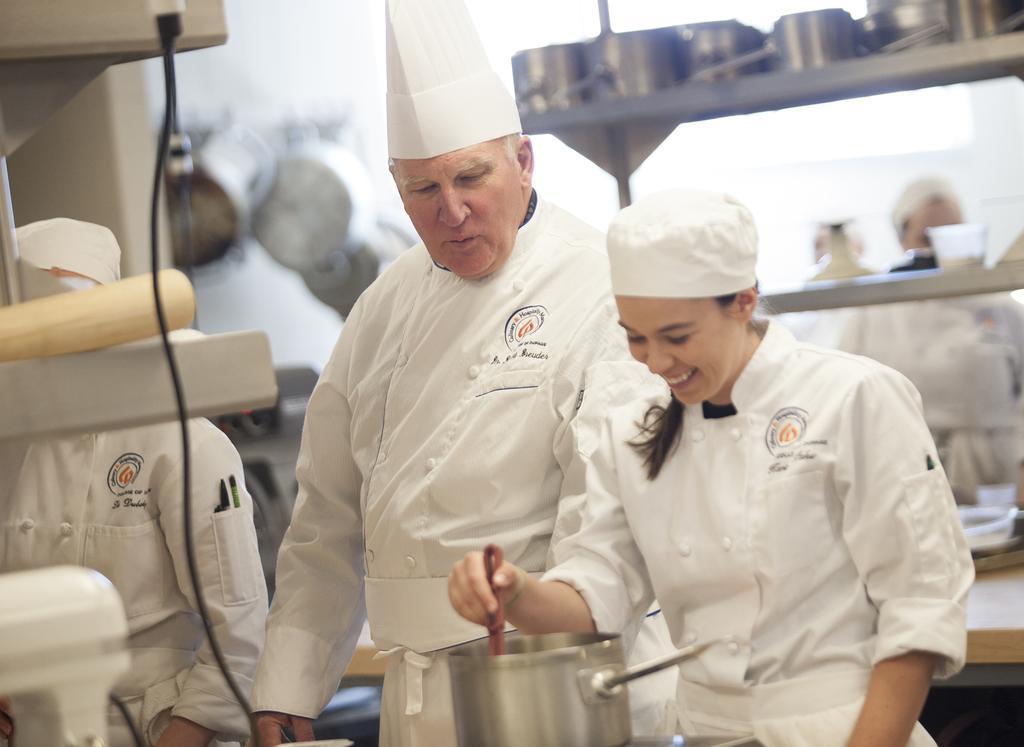In one or two sentences, can you explain what this image depicts? In the middle of the image two persons standing she is holding a spoon. Bottom of the image there is a bowl. Bottom left side of the image a person is standing and there is a wire and there are some products. Top right side of the image there is a table, on the table there are some bowls and cups. Behind the table few people are standing. 